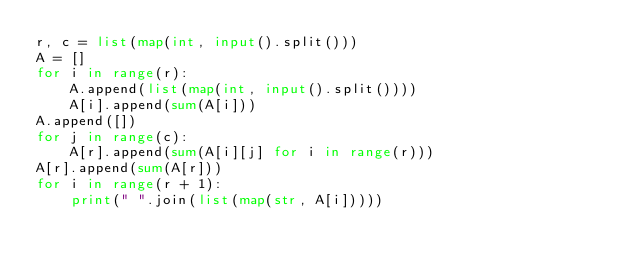Convert code to text. <code><loc_0><loc_0><loc_500><loc_500><_Python_>r, c = list(map(int, input().split()))
A = []
for i in range(r):
    A.append(list(map(int, input().split())))
    A[i].append(sum(A[i]))
A.append([])
for j in range(c):
    A[r].append(sum(A[i][j] for i in range(r)))
A[r].append(sum(A[r]))
for i in range(r + 1):
    print(" ".join(list(map(str, A[i]))))</code> 